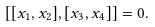Convert formula to latex. <formula><loc_0><loc_0><loc_500><loc_500>[ [ x _ { 1 } , x _ { 2 } ] , [ x _ { 3 } , x _ { 4 } ] ] = 0 .</formula> 